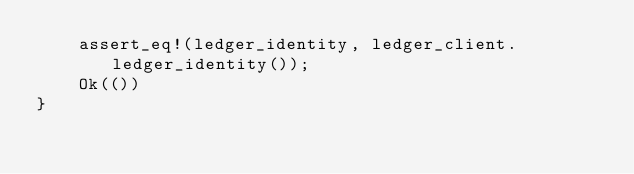Convert code to text. <code><loc_0><loc_0><loc_500><loc_500><_Rust_>    assert_eq!(ledger_identity, ledger_client.ledger_identity());
    Ok(())
}
</code> 